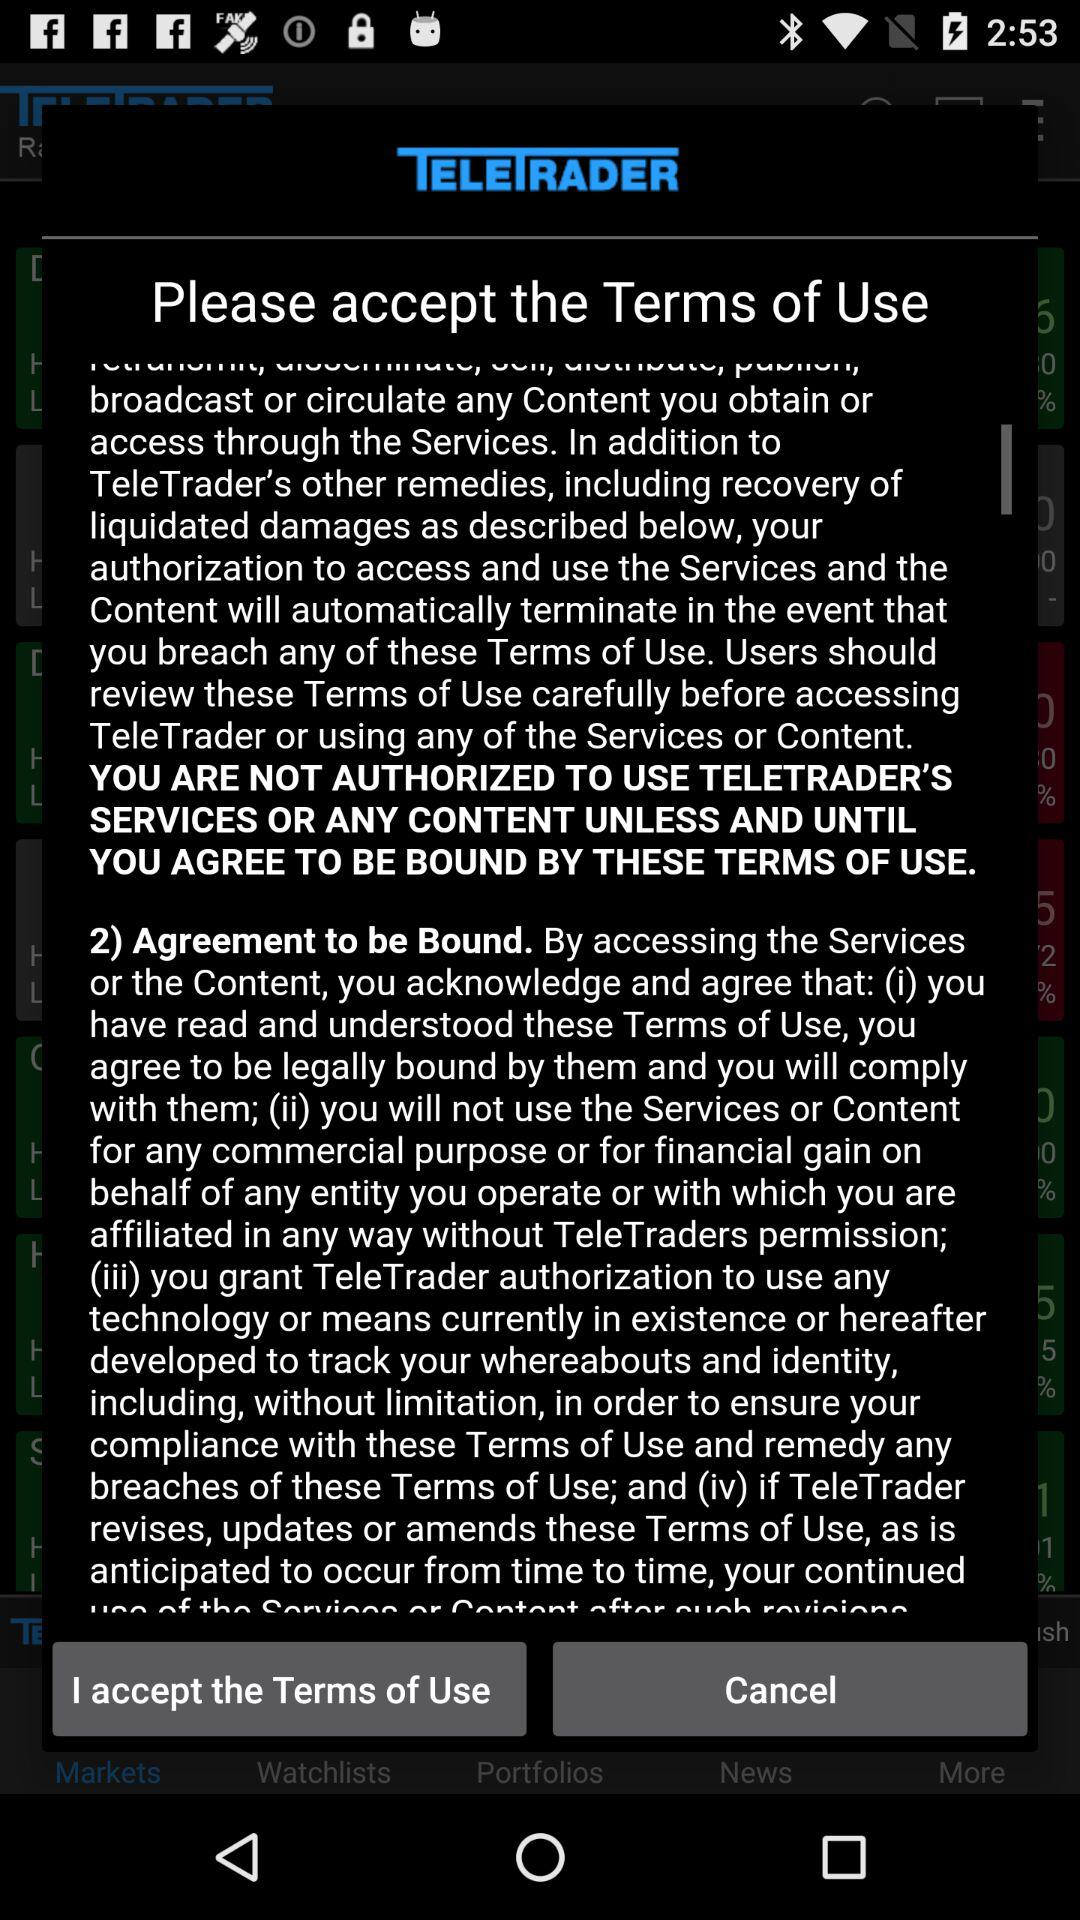When will I be able to use the application? You will be able to use the application when you agree to be bound by the terms of use. 